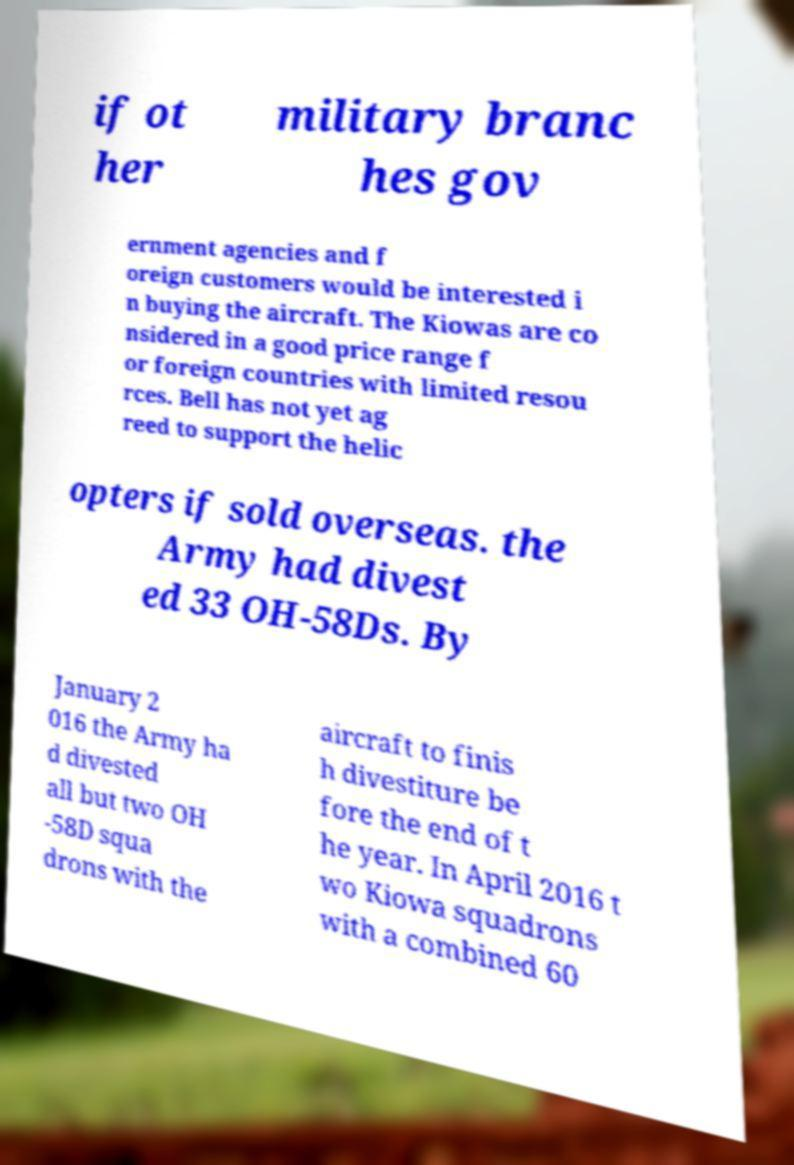Please identify and transcribe the text found in this image. if ot her military branc hes gov ernment agencies and f oreign customers would be interested i n buying the aircraft. The Kiowas are co nsidered in a good price range f or foreign countries with limited resou rces. Bell has not yet ag reed to support the helic opters if sold overseas. the Army had divest ed 33 OH-58Ds. By January 2 016 the Army ha d divested all but two OH -58D squa drons with the aircraft to finis h divestiture be fore the end of t he year. In April 2016 t wo Kiowa squadrons with a combined 60 